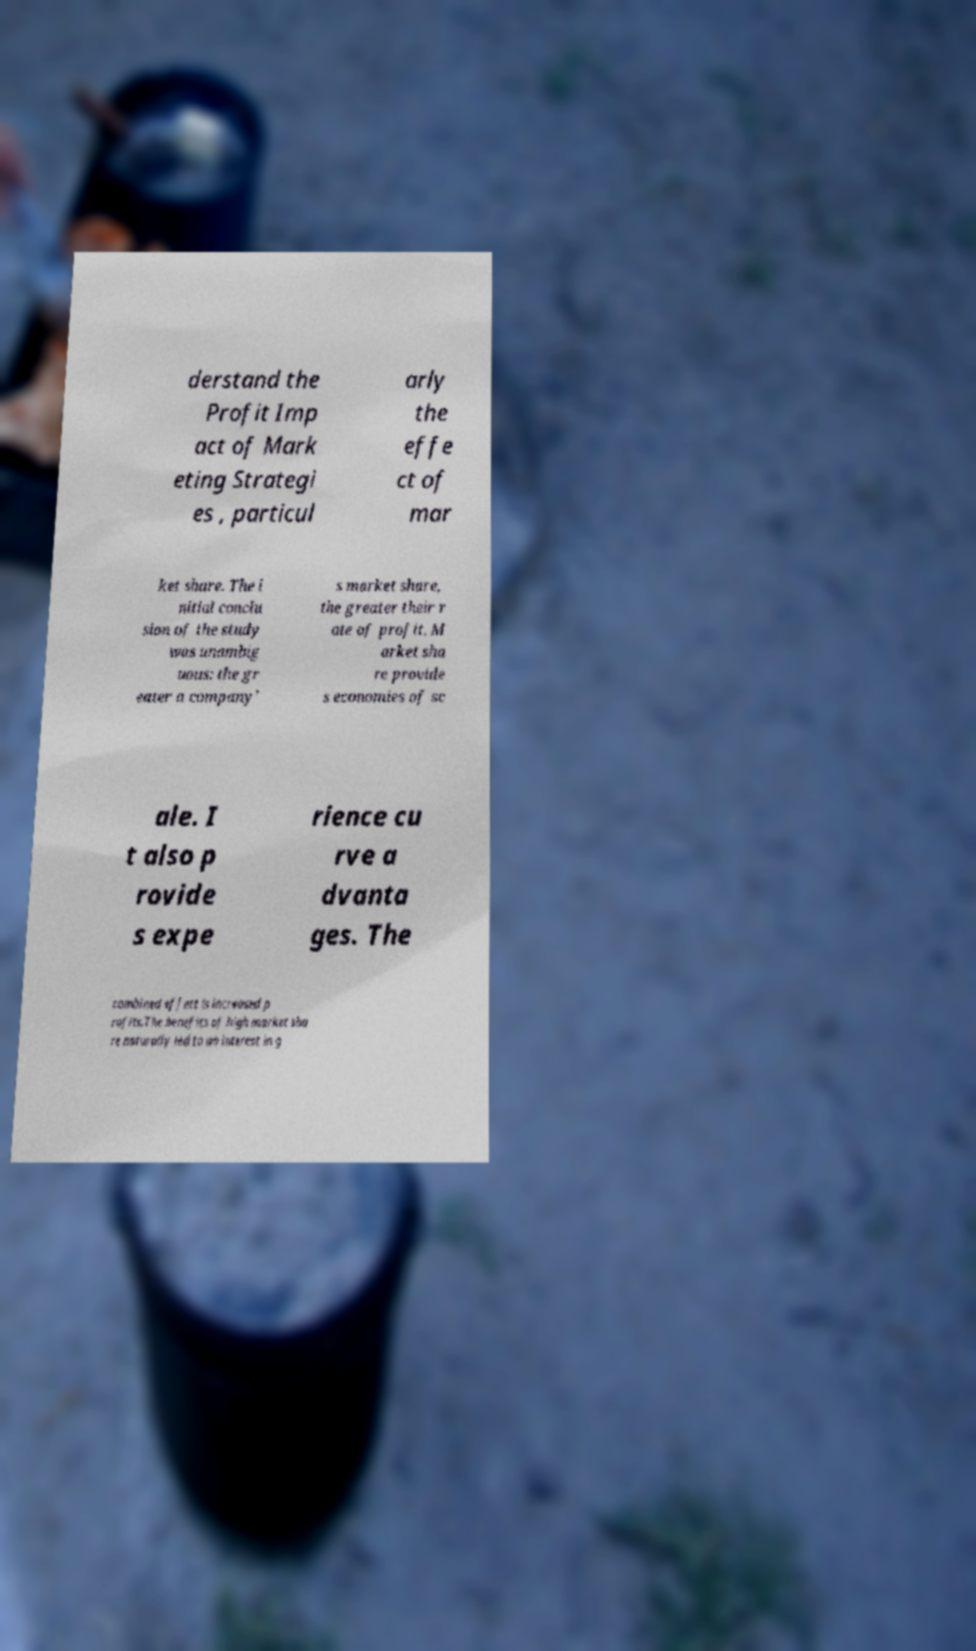Can you accurately transcribe the text from the provided image for me? derstand the Profit Imp act of Mark eting Strategi es , particul arly the effe ct of mar ket share. The i nitial conclu sion of the study was unambig uous: the gr eater a company' s market share, the greater their r ate of profit. M arket sha re provide s economies of sc ale. I t also p rovide s expe rience cu rve a dvanta ges. The combined effect is increased p rofits.The benefits of high market sha re naturally led to an interest in g 